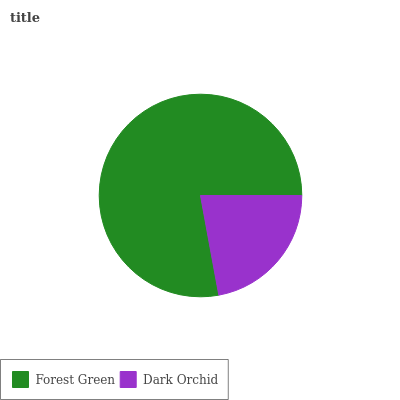Is Dark Orchid the minimum?
Answer yes or no. Yes. Is Forest Green the maximum?
Answer yes or no. Yes. Is Dark Orchid the maximum?
Answer yes or no. No. Is Forest Green greater than Dark Orchid?
Answer yes or no. Yes. Is Dark Orchid less than Forest Green?
Answer yes or no. Yes. Is Dark Orchid greater than Forest Green?
Answer yes or no. No. Is Forest Green less than Dark Orchid?
Answer yes or no. No. Is Forest Green the high median?
Answer yes or no. Yes. Is Dark Orchid the low median?
Answer yes or no. Yes. Is Dark Orchid the high median?
Answer yes or no. No. Is Forest Green the low median?
Answer yes or no. No. 